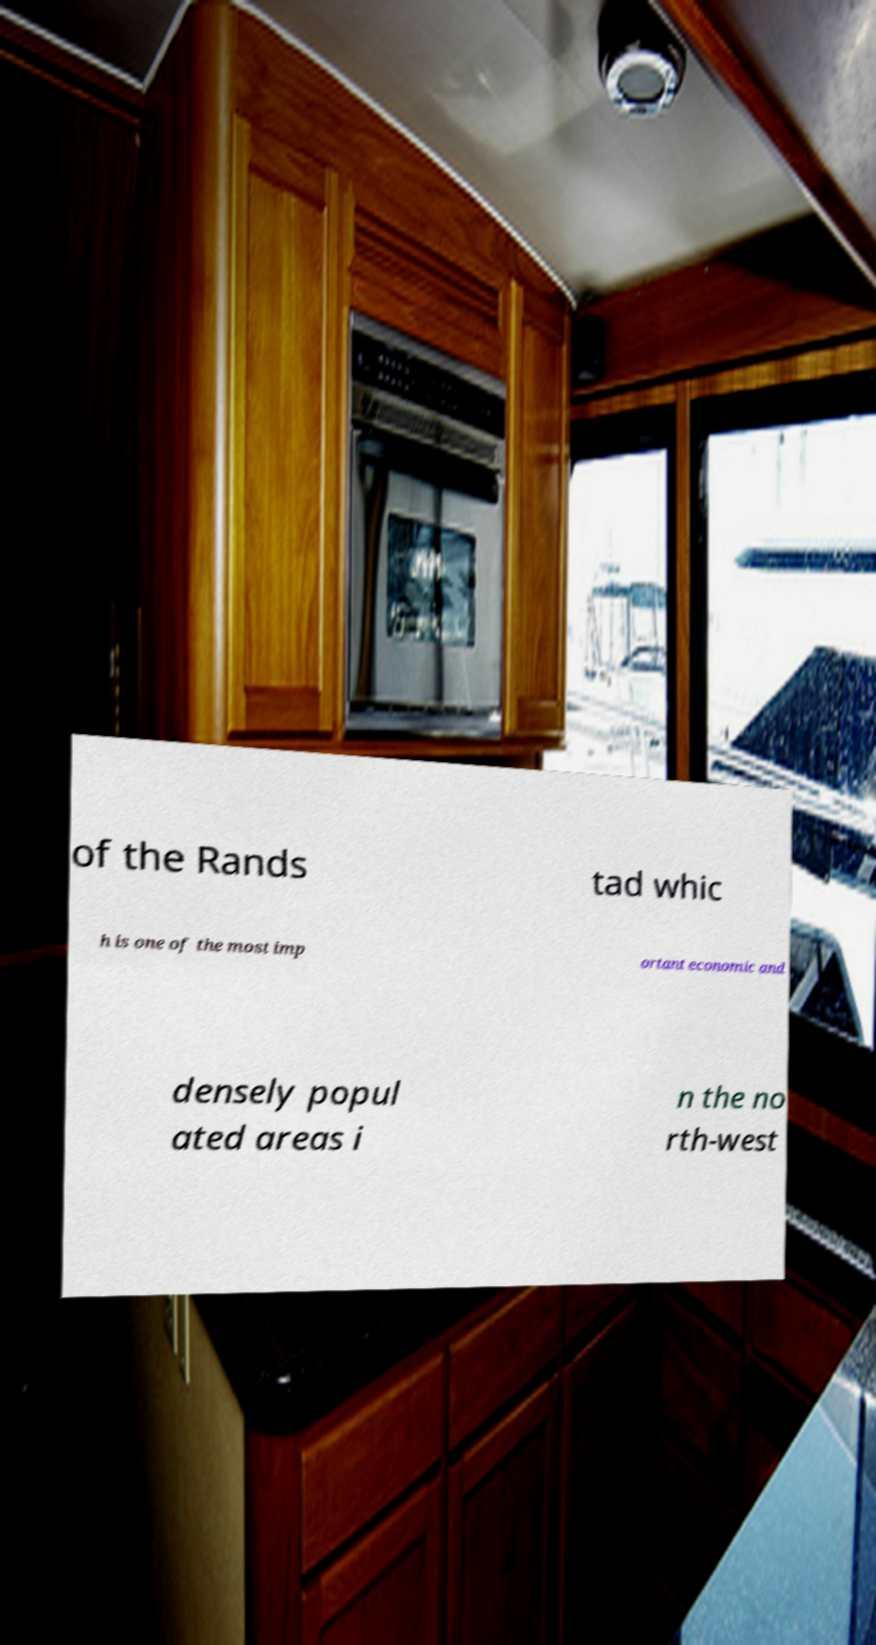Could you extract and type out the text from this image? of the Rands tad whic h is one of the most imp ortant economic and densely popul ated areas i n the no rth-west 